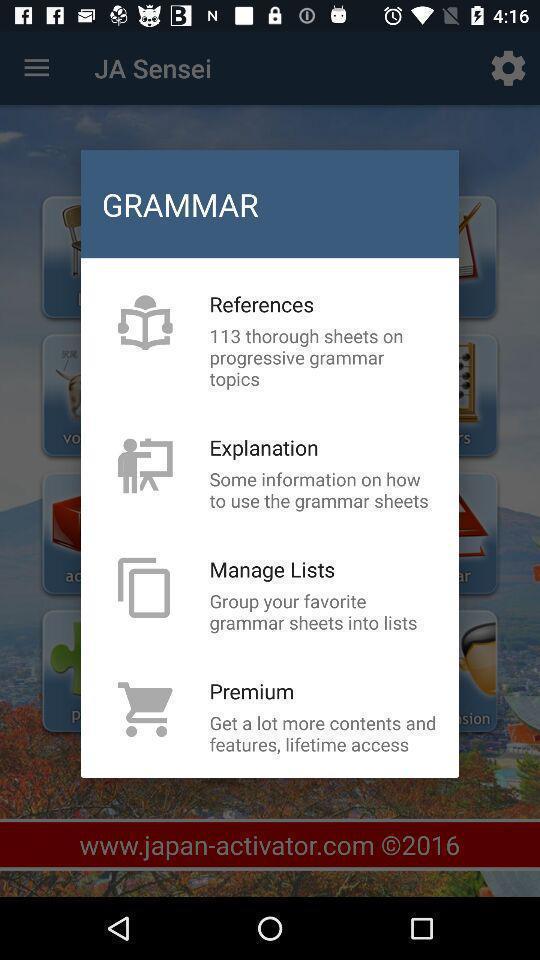Explain what's happening in this screen capture. Popup displaying options to choose. 